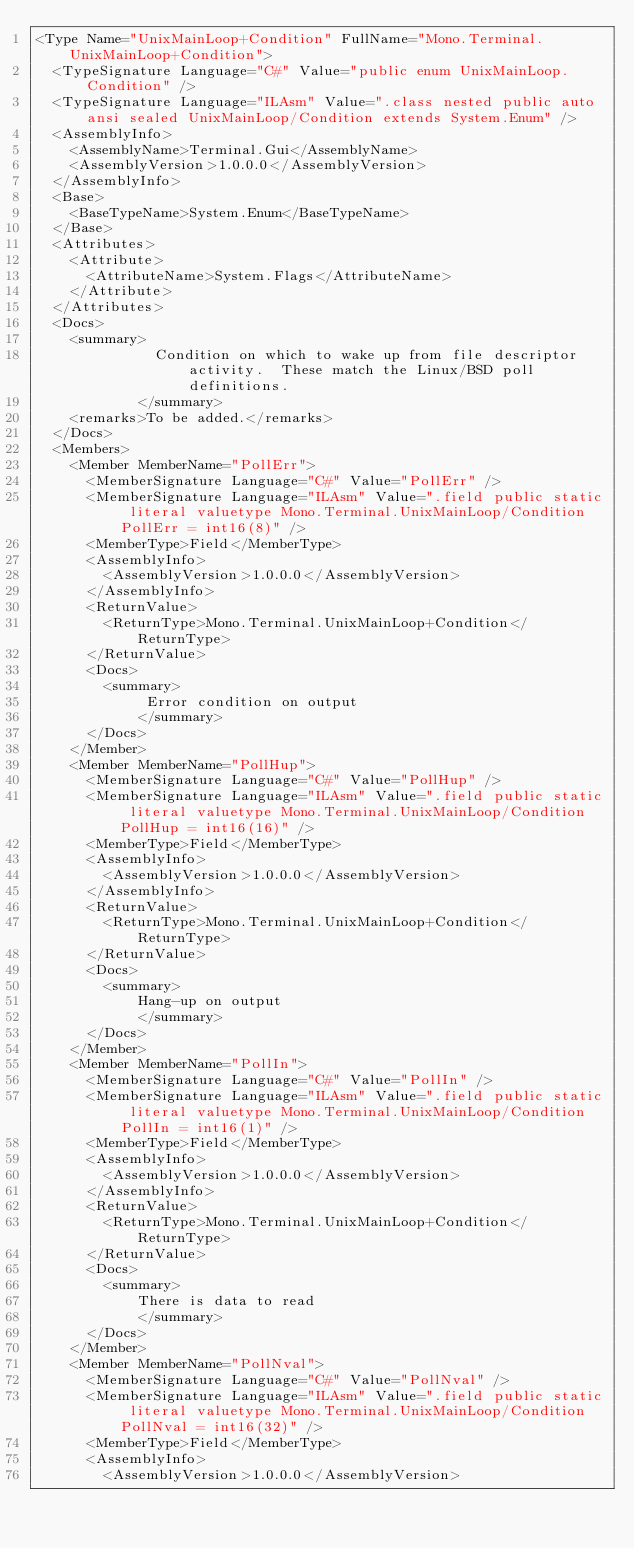Convert code to text. <code><loc_0><loc_0><loc_500><loc_500><_XML_><Type Name="UnixMainLoop+Condition" FullName="Mono.Terminal.UnixMainLoop+Condition">
  <TypeSignature Language="C#" Value="public enum UnixMainLoop.Condition" />
  <TypeSignature Language="ILAsm" Value=".class nested public auto ansi sealed UnixMainLoop/Condition extends System.Enum" />
  <AssemblyInfo>
    <AssemblyName>Terminal.Gui</AssemblyName>
    <AssemblyVersion>1.0.0.0</AssemblyVersion>
  </AssemblyInfo>
  <Base>
    <BaseTypeName>System.Enum</BaseTypeName>
  </Base>
  <Attributes>
    <Attribute>
      <AttributeName>System.Flags</AttributeName>
    </Attribute>
  </Attributes>
  <Docs>
    <summary>
              Condition on which to wake up from file descriptor activity.  These match the Linux/BSD poll definitions.
            </summary>
    <remarks>To be added.</remarks>
  </Docs>
  <Members>
    <Member MemberName="PollErr">
      <MemberSignature Language="C#" Value="PollErr" />
      <MemberSignature Language="ILAsm" Value=".field public static literal valuetype Mono.Terminal.UnixMainLoop/Condition PollErr = int16(8)" />
      <MemberType>Field</MemberType>
      <AssemblyInfo>
        <AssemblyVersion>1.0.0.0</AssemblyVersion>
      </AssemblyInfo>
      <ReturnValue>
        <ReturnType>Mono.Terminal.UnixMainLoop+Condition</ReturnType>
      </ReturnValue>
      <Docs>
        <summary>
             Error condition on output
            </summary>
      </Docs>
    </Member>
    <Member MemberName="PollHup">
      <MemberSignature Language="C#" Value="PollHup" />
      <MemberSignature Language="ILAsm" Value=".field public static literal valuetype Mono.Terminal.UnixMainLoop/Condition PollHup = int16(16)" />
      <MemberType>Field</MemberType>
      <AssemblyInfo>
        <AssemblyVersion>1.0.0.0</AssemblyVersion>
      </AssemblyInfo>
      <ReturnValue>
        <ReturnType>Mono.Terminal.UnixMainLoop+Condition</ReturnType>
      </ReturnValue>
      <Docs>
        <summary>
            Hang-up on output
            </summary>
      </Docs>
    </Member>
    <Member MemberName="PollIn">
      <MemberSignature Language="C#" Value="PollIn" />
      <MemberSignature Language="ILAsm" Value=".field public static literal valuetype Mono.Terminal.UnixMainLoop/Condition PollIn = int16(1)" />
      <MemberType>Field</MemberType>
      <AssemblyInfo>
        <AssemblyVersion>1.0.0.0</AssemblyVersion>
      </AssemblyInfo>
      <ReturnValue>
        <ReturnType>Mono.Terminal.UnixMainLoop+Condition</ReturnType>
      </ReturnValue>
      <Docs>
        <summary>
            There is data to read
            </summary>
      </Docs>
    </Member>
    <Member MemberName="PollNval">
      <MemberSignature Language="C#" Value="PollNval" />
      <MemberSignature Language="ILAsm" Value=".field public static literal valuetype Mono.Terminal.UnixMainLoop/Condition PollNval = int16(32)" />
      <MemberType>Field</MemberType>
      <AssemblyInfo>
        <AssemblyVersion>1.0.0.0</AssemblyVersion></code> 